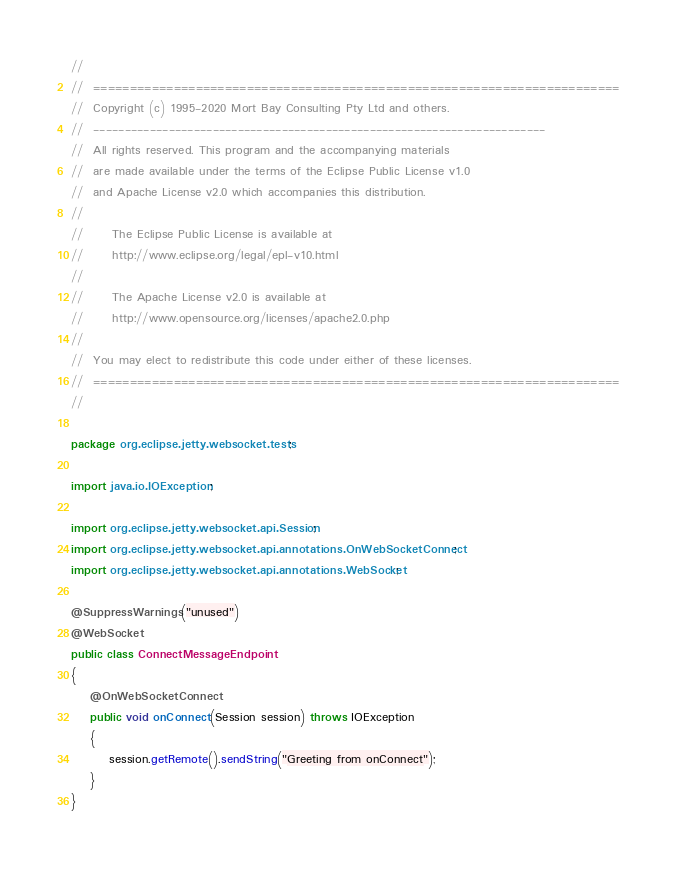<code> <loc_0><loc_0><loc_500><loc_500><_Java_>//
//  ========================================================================
//  Copyright (c) 1995-2020 Mort Bay Consulting Pty Ltd and others.
//  ------------------------------------------------------------------------
//  All rights reserved. This program and the accompanying materials
//  are made available under the terms of the Eclipse Public License v1.0
//  and Apache License v2.0 which accompanies this distribution.
//
//      The Eclipse Public License is available at
//      http://www.eclipse.org/legal/epl-v10.html
//
//      The Apache License v2.0 is available at
//      http://www.opensource.org/licenses/apache2.0.php
//
//  You may elect to redistribute this code under either of these licenses.
//  ========================================================================
//

package org.eclipse.jetty.websocket.tests;

import java.io.IOException;

import org.eclipse.jetty.websocket.api.Session;
import org.eclipse.jetty.websocket.api.annotations.OnWebSocketConnect;
import org.eclipse.jetty.websocket.api.annotations.WebSocket;

@SuppressWarnings("unused")
@WebSocket
public class ConnectMessageEndpoint
{
    @OnWebSocketConnect
    public void onConnect(Session session) throws IOException
    {
        session.getRemote().sendString("Greeting from onConnect");
    }
}
</code> 